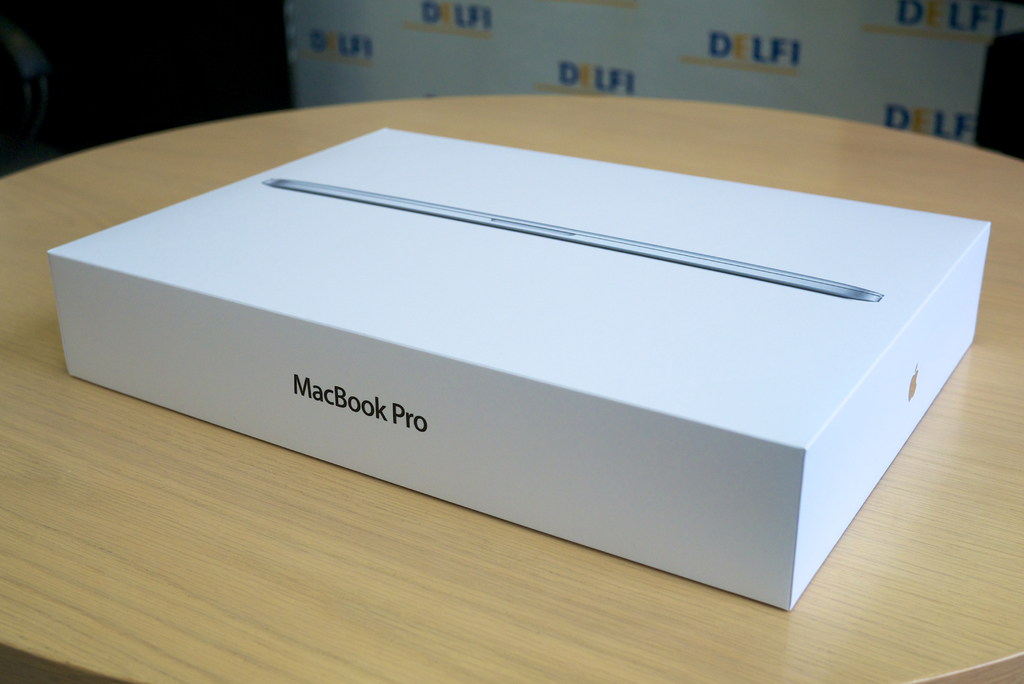Can you speculate why a MacBook Pro box would be placed in a deli environment? This unique placement might be part of a marketing strategy aimed at associating the MacBook Pro with lifestyle elements beyond just technology. By positioning it in a casual and commonly frequented place like a deli, the idea might be to showcase the MacBook as an integral part of everyday, modern life, appealing to customers who value both tradition and the latest technology. 